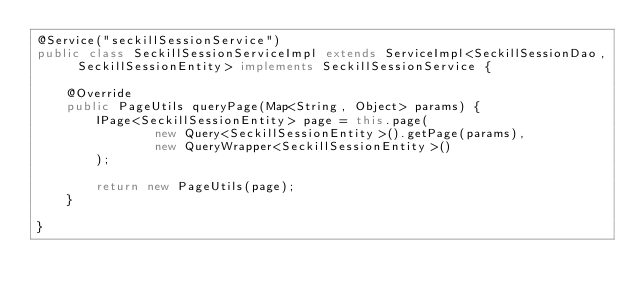Convert code to text. <code><loc_0><loc_0><loc_500><loc_500><_Java_>@Service("seckillSessionService")
public class SeckillSessionServiceImpl extends ServiceImpl<SeckillSessionDao, SeckillSessionEntity> implements SeckillSessionService {

    @Override
    public PageUtils queryPage(Map<String, Object> params) {
        IPage<SeckillSessionEntity> page = this.page(
                new Query<SeckillSessionEntity>().getPage(params),
                new QueryWrapper<SeckillSessionEntity>()
        );

        return new PageUtils(page);
    }

}</code> 